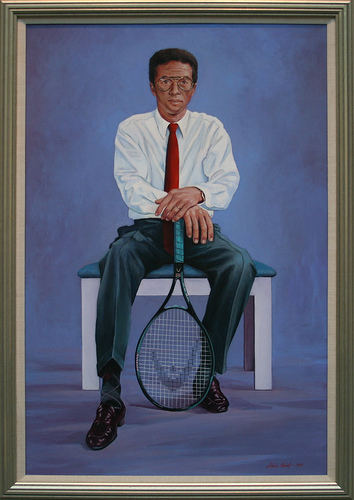Please provide the bounding box coordinate of the region this sentence describes: deep red tie. The deep red tie is found approximately within coordinates [0.47, 0.25, 0.52, 0.5]. 